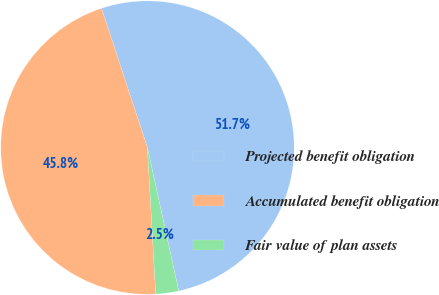<chart> <loc_0><loc_0><loc_500><loc_500><pie_chart><fcel>Projected benefit obligation<fcel>Accumulated benefit obligation<fcel>Fair value of plan assets<nl><fcel>51.65%<fcel>45.82%<fcel>2.52%<nl></chart> 